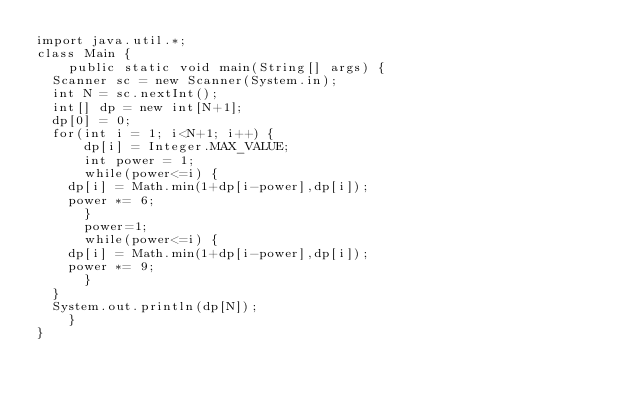Convert code to text. <code><loc_0><loc_0><loc_500><loc_500><_Java_>import java.util.*;
class Main {
    public static void main(String[] args) {
	Scanner sc = new Scanner(System.in);
	int N = sc.nextInt();
	int[] dp = new int[N+1];
	dp[0] = 0;
	for(int i = 1; i<N+1; i++) {
	    dp[i] = Integer.MAX_VALUE;
	    int power = 1;
	    while(power<=i) {
		dp[i] = Math.min(1+dp[i-power],dp[i]);
		power *= 6;
	    }
	    power=1;
	    while(power<=i) {
		dp[i] = Math.min(1+dp[i-power],dp[i]);
		power *= 9;
	    }
	}
	System.out.println(dp[N]);
    }
}</code> 